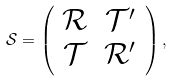Convert formula to latex. <formula><loc_0><loc_0><loc_500><loc_500>\mathcal { S } = \left ( \begin{array} { c c } \mathcal { R } & \mathcal { T } ^ { \prime } \\ \mathcal { T } & \mathcal { R } ^ { \prime } \end{array} \right ) ,</formula> 